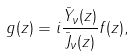<formula> <loc_0><loc_0><loc_500><loc_500>g ( z ) = i \frac { \bar { Y } _ { \nu } ( z ) } { \bar { J } _ { \nu } ( z ) } f ( z ) ,</formula> 